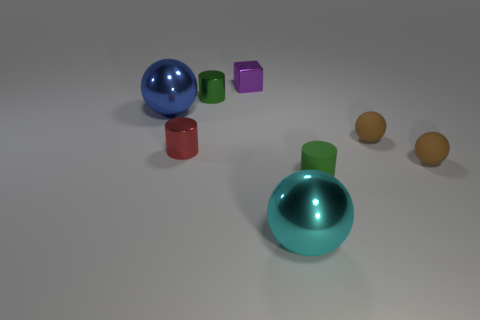Add 2 tiny purple blocks. How many objects exist? 10 Subtract all cylinders. How many objects are left? 5 Subtract all spheres. Subtract all small metal cylinders. How many objects are left? 2 Add 8 large shiny spheres. How many large shiny spheres are left? 10 Add 4 big cyan shiny cubes. How many big cyan shiny cubes exist? 4 Subtract 1 blue spheres. How many objects are left? 7 